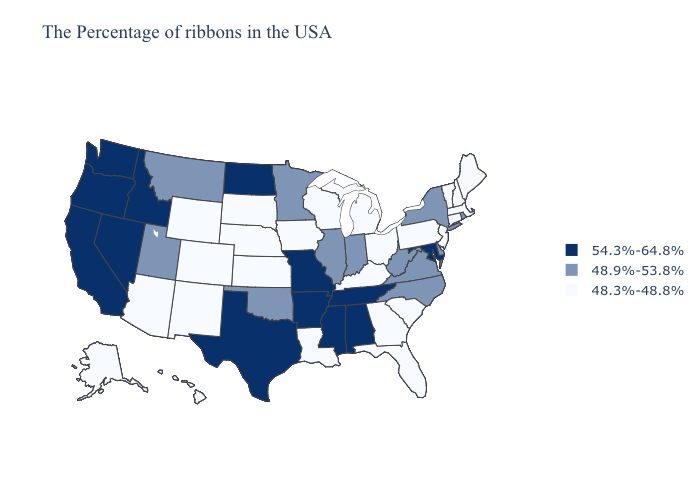What is the value of Wisconsin?
Give a very brief answer. 48.3%-48.8%. Does the first symbol in the legend represent the smallest category?
Be succinct. No. Name the states that have a value in the range 54.3%-64.8%?
Be succinct. Maryland, Alabama, Tennessee, Mississippi, Missouri, Arkansas, Texas, North Dakota, Idaho, Nevada, California, Washington, Oregon. What is the highest value in the Northeast ?
Write a very short answer. 48.9%-53.8%. Among the states that border Massachusetts , which have the lowest value?
Give a very brief answer. New Hampshire, Vermont, Connecticut. What is the value of Arizona?
Keep it brief. 48.3%-48.8%. Among the states that border Florida , does Georgia have the lowest value?
Keep it brief. Yes. What is the value of Utah?
Be succinct. 48.9%-53.8%. What is the value of New York?
Quick response, please. 48.9%-53.8%. What is the lowest value in the USA?
Give a very brief answer. 48.3%-48.8%. What is the lowest value in states that border Maine?
Answer briefly. 48.3%-48.8%. What is the value of New Jersey?
Be succinct. 48.3%-48.8%. Among the states that border Virginia , does Kentucky have the lowest value?
Give a very brief answer. Yes. What is the lowest value in states that border Indiana?
Write a very short answer. 48.3%-48.8%. Which states have the lowest value in the West?
Give a very brief answer. Wyoming, Colorado, New Mexico, Arizona, Alaska, Hawaii. 